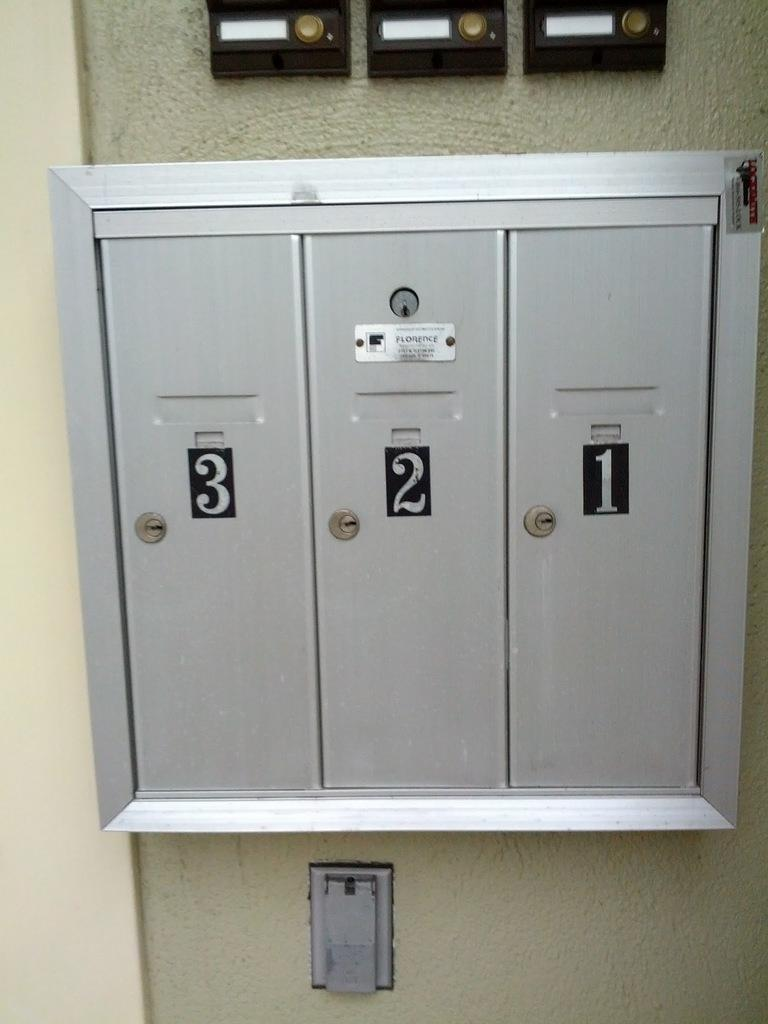What is attached to the wall in the image? There is a locker on the wall in the image. Are there any other objects on the wall besides the locker? Yes, there are other objects on the wall in the image. What type of blade can be seen cutting through the oatmeal in the image? There is no blade or oatmeal present in the image; it only features a locker and other objects on the wall. 